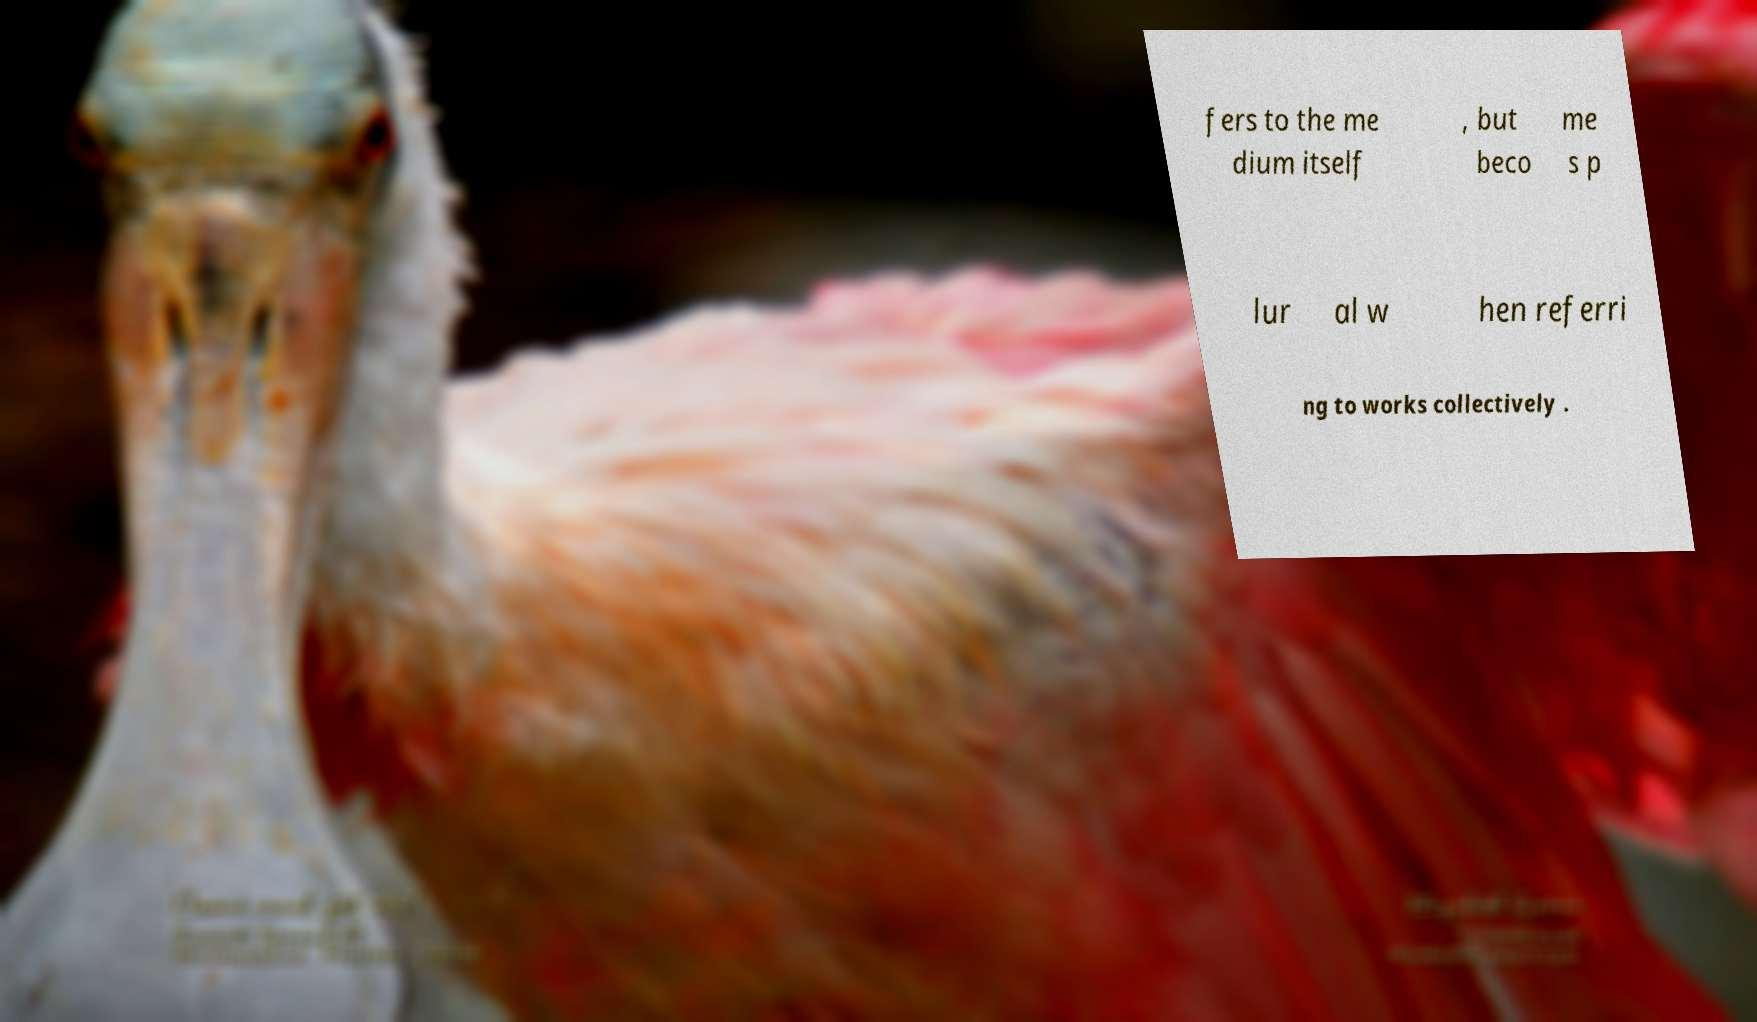Can you accurately transcribe the text from the provided image for me? fers to the me dium itself , but beco me s p lur al w hen referri ng to works collectively . 